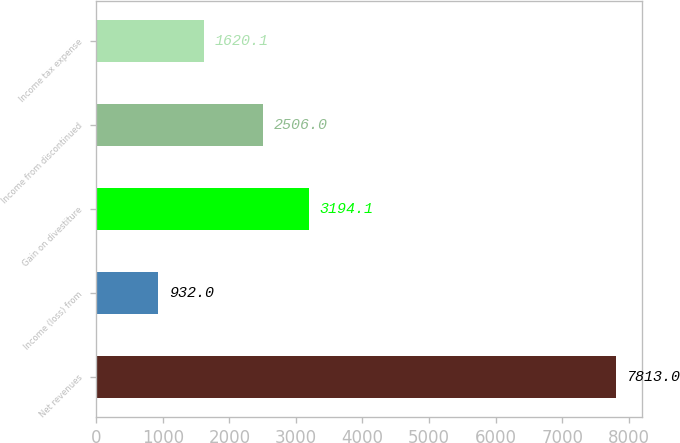<chart> <loc_0><loc_0><loc_500><loc_500><bar_chart><fcel>Net revenues<fcel>Income (loss) from<fcel>Gain on divestiture<fcel>Income from discontinued<fcel>Income tax expense<nl><fcel>7813<fcel>932<fcel>3194.1<fcel>2506<fcel>1620.1<nl></chart> 